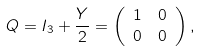<formula> <loc_0><loc_0><loc_500><loc_500>Q & = I _ { 3 } + \frac { Y } { 2 } = \left ( \begin{array} { c c } 1 & 0 \\ 0 & 0 \end{array} \right ) ,</formula> 